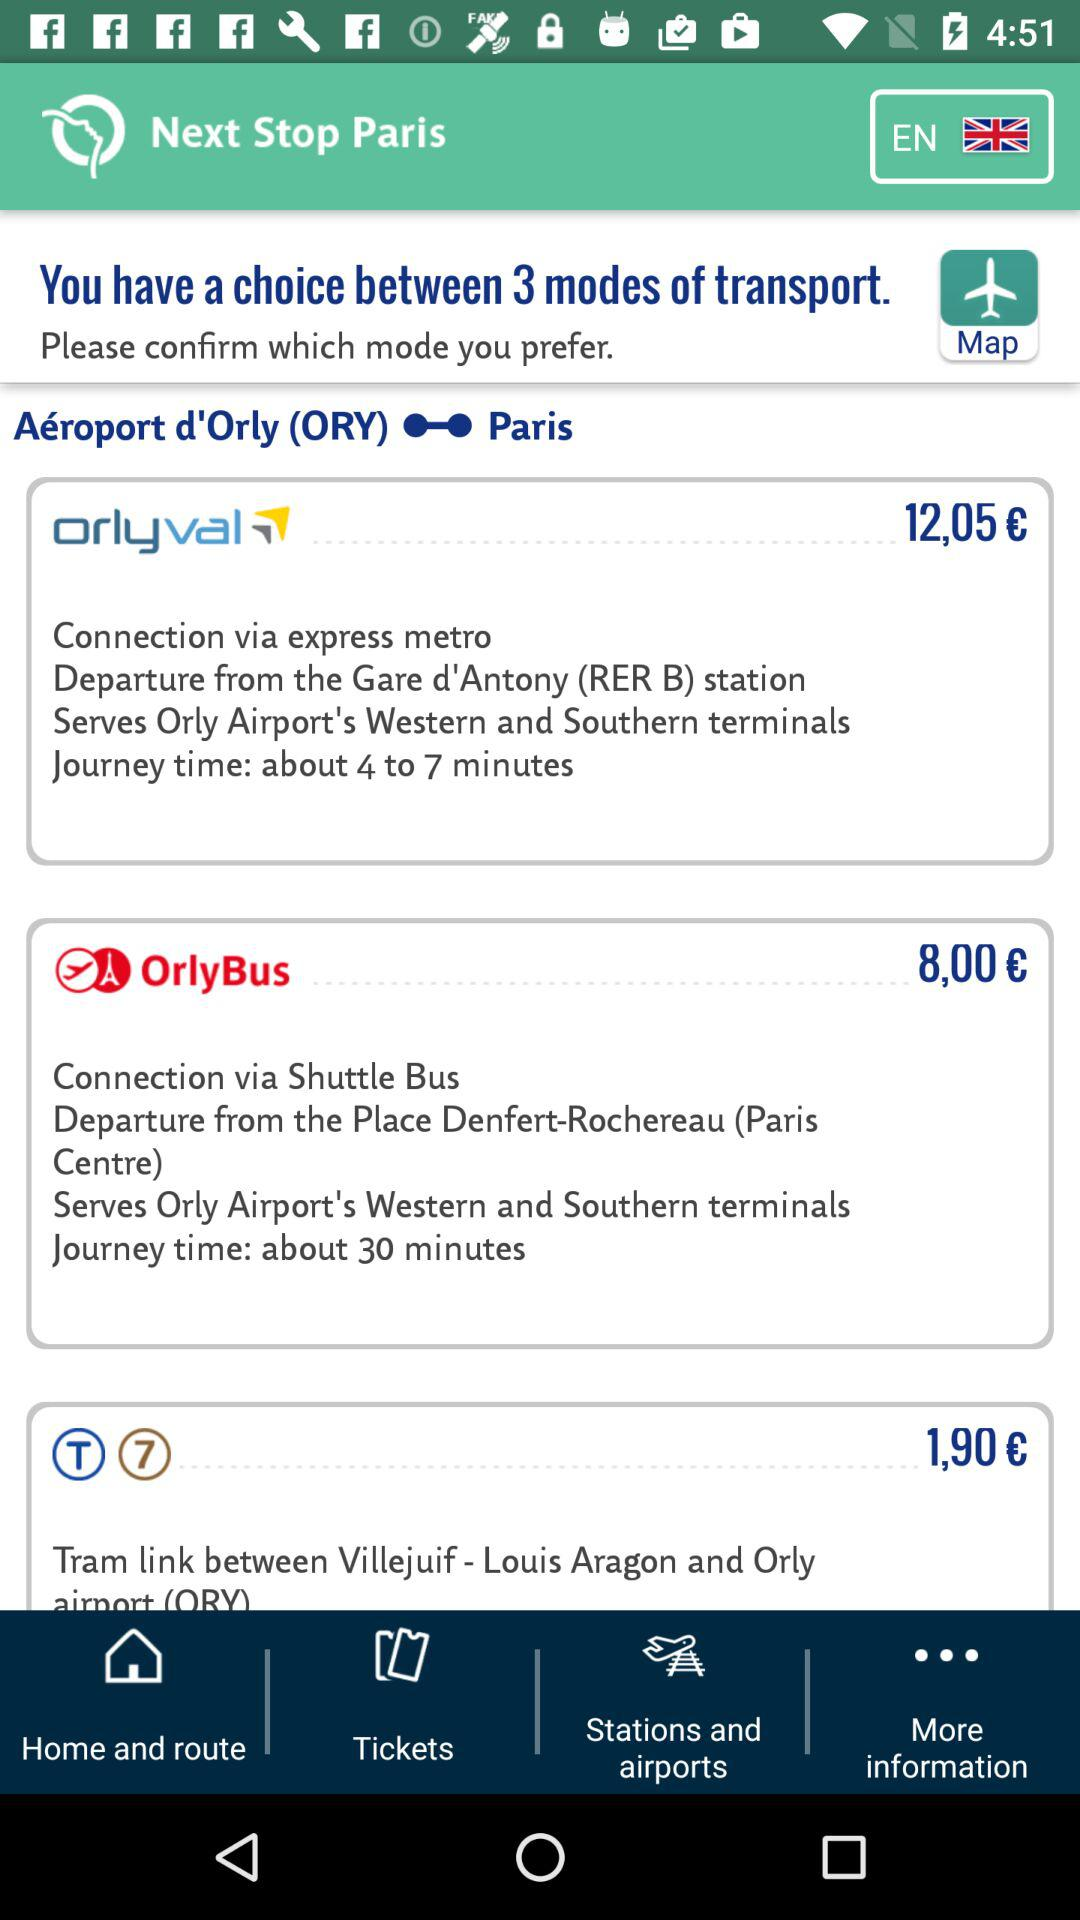How much time does it take for Orlyval? It takes about 4 to 7 minutes for Orlyval. 